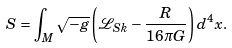<formula> <loc_0><loc_0><loc_500><loc_500>S = \int _ { M } \sqrt { - g } \left ( \mathcal { L } _ { S k } - \frac { R } { 1 6 \pi G } \right ) d ^ { 4 } x .</formula> 